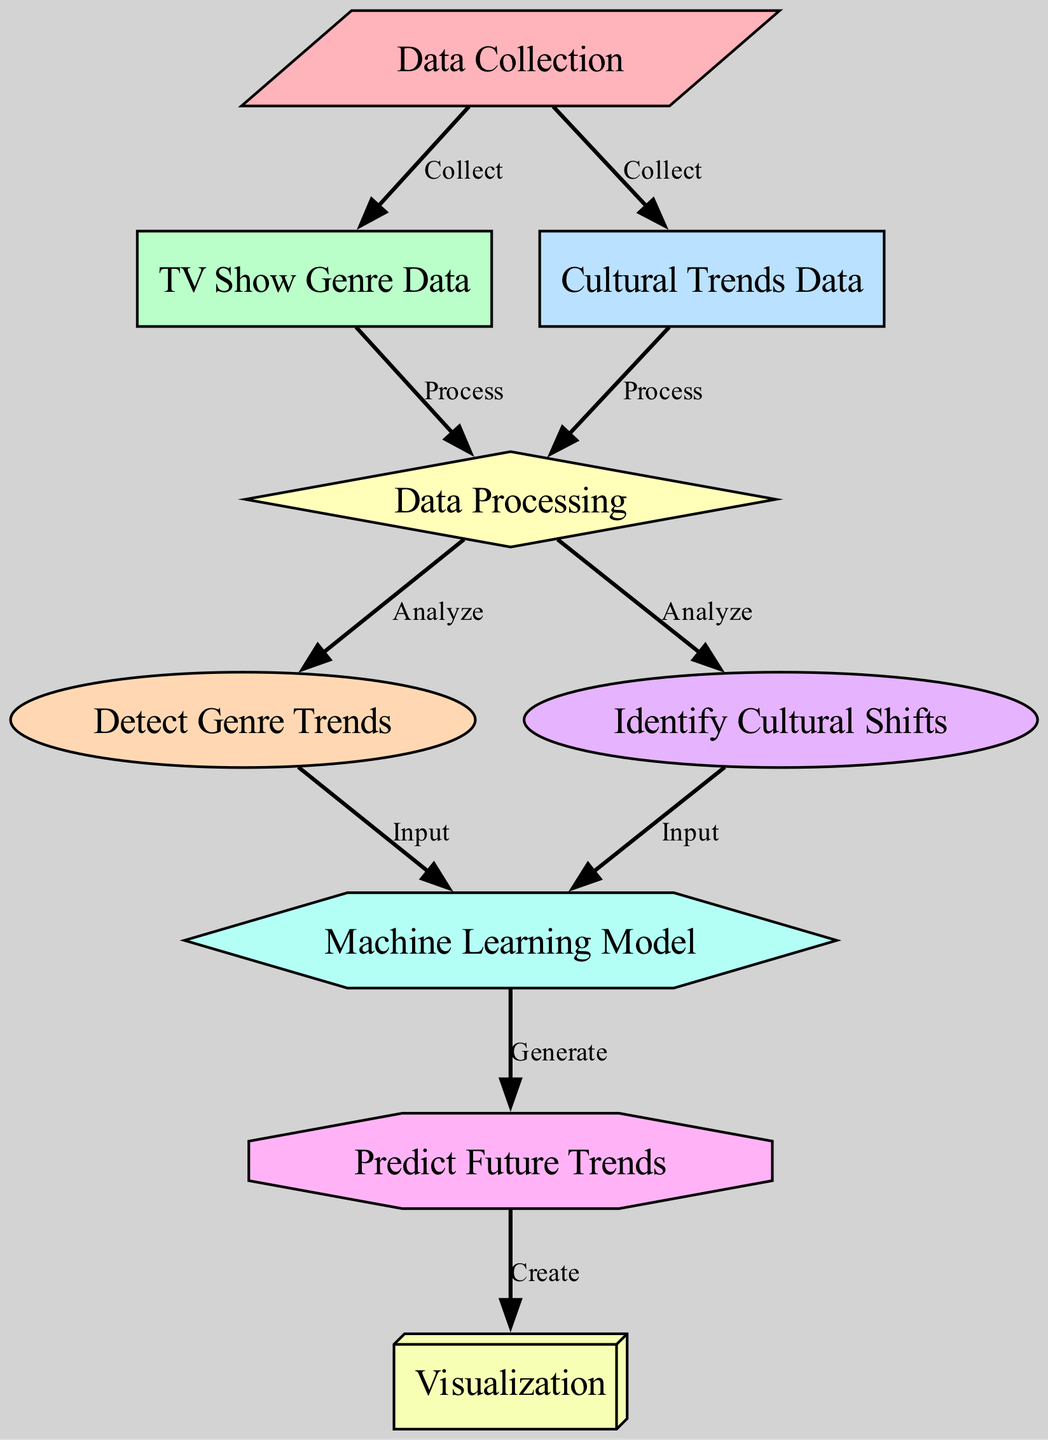What is the total number of nodes in the diagram? The diagram lists 9 distinct nodes: Data Collection, TV Show Genre Data, Cultural Trends Data, Data Processing, Detect Genre Trends, Identify Cultural Shifts, Machine Learning Model, Predict Future Trends, and Visualization. Counting these gives a total of 9 nodes.
Answer: 9 What is the label for the node that collects cultural trends data? The node that represents data collection for cultural trends is labeled "Cultural Trends Data." This information is directly reflected in the diagram as one of the nodes associated with data collection.
Answer: Cultural Trends Data Which node processes both genre data and cultural data? The node labeled "Data Processing" processes inputs from both "TV Show Genre Data" and "Cultural Trends Data." The edges leading to this node indicate it takes in data from these two sources, thus fulfilling this function.
Answer: Data Processing What shapes are used for the "Detect Genre Trends" and "Identify Cultural Shifts" nodes? The shapes of both nodes are ellipses, as denoted by their respective designs in the diagram. This shape is consistently used for both nodes, indicating a similar type of operation in the analysis process.
Answer: Ellipse Which node generates predictions? The node that generates predictions is labeled "Predict Future Trends." This node receives input from the machine learning model, linking the analysis into actionable forecasts regarding TV show genre trends.
Answer: Predict Future Trends How many edges are there in total? There are 10 edges connecting the nodes, as shown in the diagram. Each edge represents a relationship between two nodes, indicating how data and processes interact within the overall framework.
Answer: 10 What type of diagram is this? This is a Machine Learning diagram, as indicated by the title in the comment and the structure that emphasizes processes involved in analyzing data to yield predictions, as per standard practices in machine learning methodologies.
Answer: Machine Learning What is the output of the "Machine Learning Model"? The output of the "Machine Learning Model" is "Generate," which indicates it produces predictions based on the analyzed genre and cultural shift data fed into it. This specific action is outlined in the diagram between the model and the prediction node.
Answer: Generate Which node is represented as a hexagon? The node represented as a hexagon is "Machine Learning Model." Its unique shape visually distinguishes it within the diagram, signifying its importance in the process of analyzing data and generating predictions.
Answer: Machine Learning Model 